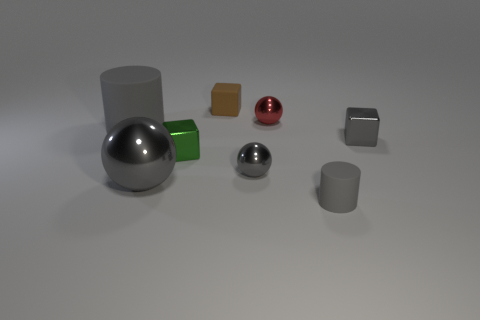Do the tiny ball in front of the gray metallic block and the big matte thing have the same color?
Offer a terse response. Yes. What is the material of the big gray object that is in front of the big gray rubber cylinder?
Give a very brief answer. Metal. What shape is the red metallic object that is the same size as the brown rubber cube?
Keep it short and to the point. Sphere. Is there a gray object of the same shape as the green shiny thing?
Ensure brevity in your answer.  Yes. Are the small gray cylinder and the cylinder on the left side of the red object made of the same material?
Your answer should be compact. Yes. There is a cylinder to the left of the rubber cylinder to the right of the small green block; what is it made of?
Provide a succinct answer. Rubber. Are there more green cubes that are to the left of the small gray cube than big purple things?
Give a very brief answer. Yes. Are there any gray metal blocks?
Offer a very short reply. Yes. The small metal sphere that is in front of the small green object is what color?
Offer a very short reply. Gray. What material is the gray cube that is the same size as the brown matte thing?
Your response must be concise. Metal. 